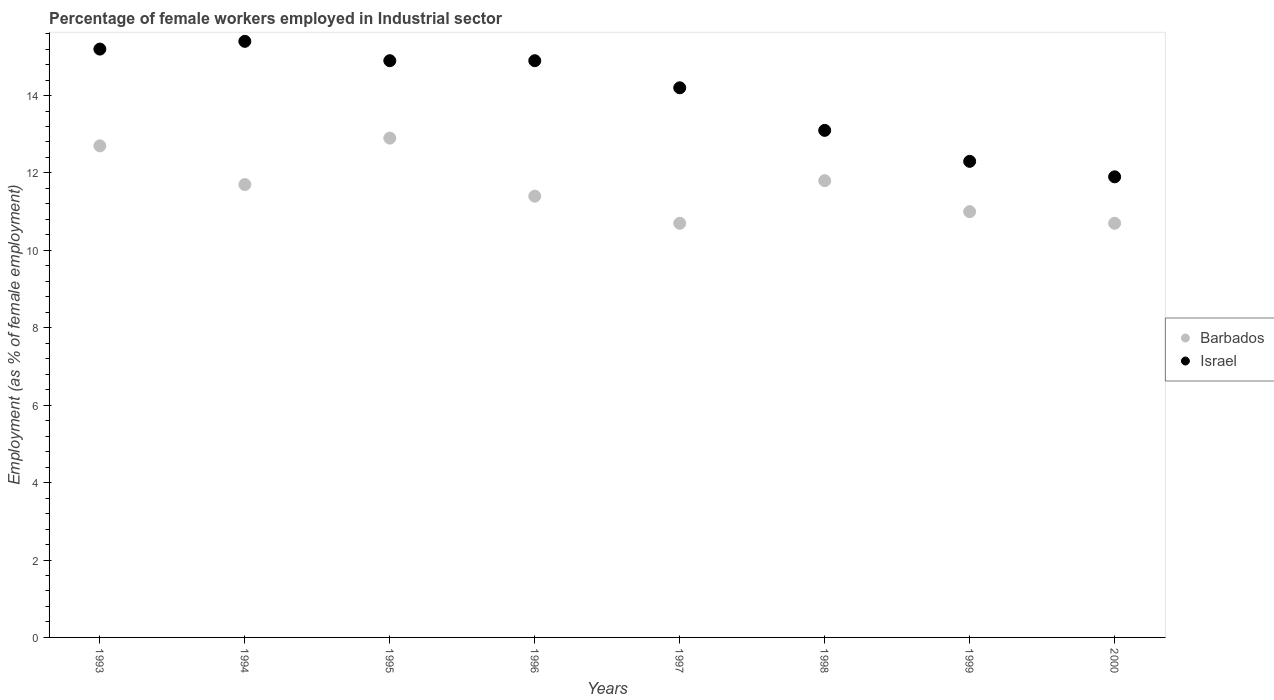What is the percentage of females employed in Industrial sector in Barbados in 1993?
Offer a very short reply. 12.7. Across all years, what is the maximum percentage of females employed in Industrial sector in Israel?
Your answer should be very brief. 15.4. Across all years, what is the minimum percentage of females employed in Industrial sector in Israel?
Offer a very short reply. 11.9. In which year was the percentage of females employed in Industrial sector in Barbados maximum?
Offer a terse response. 1995. What is the total percentage of females employed in Industrial sector in Barbados in the graph?
Ensure brevity in your answer.  92.9. What is the difference between the percentage of females employed in Industrial sector in Barbados in 1996 and that in 2000?
Your response must be concise. 0.7. What is the difference between the percentage of females employed in Industrial sector in Barbados in 1998 and the percentage of females employed in Industrial sector in Israel in 1997?
Provide a short and direct response. -2.4. What is the average percentage of females employed in Industrial sector in Israel per year?
Your answer should be very brief. 13.99. In the year 1998, what is the difference between the percentage of females employed in Industrial sector in Israel and percentage of females employed in Industrial sector in Barbados?
Your response must be concise. 1.3. In how many years, is the percentage of females employed in Industrial sector in Barbados greater than 9.6 %?
Your answer should be compact. 8. What is the ratio of the percentage of females employed in Industrial sector in Barbados in 1998 to that in 1999?
Offer a terse response. 1.07. What is the difference between the highest and the second highest percentage of females employed in Industrial sector in Barbados?
Offer a terse response. 0.2. How many dotlines are there?
Provide a succinct answer. 2. How many years are there in the graph?
Your answer should be compact. 8. What is the difference between two consecutive major ticks on the Y-axis?
Ensure brevity in your answer.  2. Are the values on the major ticks of Y-axis written in scientific E-notation?
Offer a terse response. No. Does the graph contain any zero values?
Your answer should be very brief. No. Does the graph contain grids?
Keep it short and to the point. No. Where does the legend appear in the graph?
Provide a succinct answer. Center right. How many legend labels are there?
Make the answer very short. 2. How are the legend labels stacked?
Provide a succinct answer. Vertical. What is the title of the graph?
Make the answer very short. Percentage of female workers employed in Industrial sector. What is the label or title of the X-axis?
Offer a terse response. Years. What is the label or title of the Y-axis?
Provide a succinct answer. Employment (as % of female employment). What is the Employment (as % of female employment) of Barbados in 1993?
Ensure brevity in your answer.  12.7. What is the Employment (as % of female employment) in Israel in 1993?
Provide a short and direct response. 15.2. What is the Employment (as % of female employment) of Barbados in 1994?
Ensure brevity in your answer.  11.7. What is the Employment (as % of female employment) of Israel in 1994?
Give a very brief answer. 15.4. What is the Employment (as % of female employment) of Barbados in 1995?
Your answer should be compact. 12.9. What is the Employment (as % of female employment) of Israel in 1995?
Your response must be concise. 14.9. What is the Employment (as % of female employment) in Barbados in 1996?
Your response must be concise. 11.4. What is the Employment (as % of female employment) of Israel in 1996?
Keep it short and to the point. 14.9. What is the Employment (as % of female employment) of Barbados in 1997?
Your answer should be very brief. 10.7. What is the Employment (as % of female employment) in Israel in 1997?
Your response must be concise. 14.2. What is the Employment (as % of female employment) of Barbados in 1998?
Offer a very short reply. 11.8. What is the Employment (as % of female employment) of Israel in 1998?
Offer a terse response. 13.1. What is the Employment (as % of female employment) in Barbados in 1999?
Make the answer very short. 11. What is the Employment (as % of female employment) of Israel in 1999?
Offer a terse response. 12.3. What is the Employment (as % of female employment) in Barbados in 2000?
Make the answer very short. 10.7. What is the Employment (as % of female employment) in Israel in 2000?
Your answer should be compact. 11.9. Across all years, what is the maximum Employment (as % of female employment) in Barbados?
Give a very brief answer. 12.9. Across all years, what is the maximum Employment (as % of female employment) in Israel?
Your answer should be very brief. 15.4. Across all years, what is the minimum Employment (as % of female employment) in Barbados?
Make the answer very short. 10.7. Across all years, what is the minimum Employment (as % of female employment) in Israel?
Make the answer very short. 11.9. What is the total Employment (as % of female employment) of Barbados in the graph?
Your answer should be very brief. 92.9. What is the total Employment (as % of female employment) in Israel in the graph?
Provide a succinct answer. 111.9. What is the difference between the Employment (as % of female employment) in Barbados in 1993 and that in 1994?
Give a very brief answer. 1. What is the difference between the Employment (as % of female employment) of Barbados in 1993 and that in 1996?
Your answer should be compact. 1.3. What is the difference between the Employment (as % of female employment) in Israel in 1993 and that in 1996?
Make the answer very short. 0.3. What is the difference between the Employment (as % of female employment) in Barbados in 1993 and that in 1997?
Your answer should be compact. 2. What is the difference between the Employment (as % of female employment) of Israel in 1993 and that in 1997?
Ensure brevity in your answer.  1. What is the difference between the Employment (as % of female employment) in Israel in 1993 and that in 1999?
Give a very brief answer. 2.9. What is the difference between the Employment (as % of female employment) in Barbados in 1993 and that in 2000?
Your response must be concise. 2. What is the difference between the Employment (as % of female employment) in Barbados in 1994 and that in 1996?
Your answer should be compact. 0.3. What is the difference between the Employment (as % of female employment) in Israel in 1994 and that in 1996?
Your answer should be compact. 0.5. What is the difference between the Employment (as % of female employment) of Barbados in 1994 and that in 1997?
Provide a short and direct response. 1. What is the difference between the Employment (as % of female employment) of Israel in 1994 and that in 1998?
Make the answer very short. 2.3. What is the difference between the Employment (as % of female employment) of Israel in 1994 and that in 1999?
Keep it short and to the point. 3.1. What is the difference between the Employment (as % of female employment) in Barbados in 1994 and that in 2000?
Ensure brevity in your answer.  1. What is the difference between the Employment (as % of female employment) in Israel in 1994 and that in 2000?
Your response must be concise. 3.5. What is the difference between the Employment (as % of female employment) of Israel in 1995 and that in 1996?
Provide a succinct answer. 0. What is the difference between the Employment (as % of female employment) of Israel in 1995 and that in 1998?
Give a very brief answer. 1.8. What is the difference between the Employment (as % of female employment) in Israel in 1995 and that in 2000?
Ensure brevity in your answer.  3. What is the difference between the Employment (as % of female employment) of Barbados in 1996 and that in 1997?
Offer a very short reply. 0.7. What is the difference between the Employment (as % of female employment) in Barbados in 1997 and that in 1998?
Offer a very short reply. -1.1. What is the difference between the Employment (as % of female employment) of Barbados in 1997 and that in 1999?
Provide a short and direct response. -0.3. What is the difference between the Employment (as % of female employment) of Barbados in 1997 and that in 2000?
Your response must be concise. 0. What is the difference between the Employment (as % of female employment) in Israel in 1997 and that in 2000?
Your response must be concise. 2.3. What is the difference between the Employment (as % of female employment) in Israel in 1998 and that in 1999?
Your answer should be very brief. 0.8. What is the difference between the Employment (as % of female employment) of Barbados in 1998 and that in 2000?
Give a very brief answer. 1.1. What is the difference between the Employment (as % of female employment) of Israel in 1998 and that in 2000?
Your answer should be very brief. 1.2. What is the difference between the Employment (as % of female employment) of Barbados in 1993 and the Employment (as % of female employment) of Israel in 1995?
Ensure brevity in your answer.  -2.2. What is the difference between the Employment (as % of female employment) in Barbados in 1993 and the Employment (as % of female employment) in Israel in 1996?
Provide a short and direct response. -2.2. What is the difference between the Employment (as % of female employment) of Barbados in 1993 and the Employment (as % of female employment) of Israel in 1997?
Your answer should be compact. -1.5. What is the difference between the Employment (as % of female employment) of Barbados in 1993 and the Employment (as % of female employment) of Israel in 1998?
Your answer should be very brief. -0.4. What is the difference between the Employment (as % of female employment) in Barbados in 1993 and the Employment (as % of female employment) in Israel in 1999?
Provide a succinct answer. 0.4. What is the difference between the Employment (as % of female employment) of Barbados in 1993 and the Employment (as % of female employment) of Israel in 2000?
Ensure brevity in your answer.  0.8. What is the difference between the Employment (as % of female employment) in Barbados in 1994 and the Employment (as % of female employment) in Israel in 1997?
Provide a short and direct response. -2.5. What is the difference between the Employment (as % of female employment) in Barbados in 1994 and the Employment (as % of female employment) in Israel in 1998?
Your response must be concise. -1.4. What is the difference between the Employment (as % of female employment) in Barbados in 1995 and the Employment (as % of female employment) in Israel in 1996?
Provide a short and direct response. -2. What is the difference between the Employment (as % of female employment) in Barbados in 1995 and the Employment (as % of female employment) in Israel in 1997?
Provide a short and direct response. -1.3. What is the difference between the Employment (as % of female employment) of Barbados in 1995 and the Employment (as % of female employment) of Israel in 1999?
Provide a short and direct response. 0.6. What is the difference between the Employment (as % of female employment) in Barbados in 1996 and the Employment (as % of female employment) in Israel in 1997?
Your answer should be compact. -2.8. What is the difference between the Employment (as % of female employment) in Barbados in 1996 and the Employment (as % of female employment) in Israel in 1998?
Provide a short and direct response. -1.7. What is the difference between the Employment (as % of female employment) in Barbados in 1996 and the Employment (as % of female employment) in Israel in 2000?
Provide a succinct answer. -0.5. What is the difference between the Employment (as % of female employment) of Barbados in 1997 and the Employment (as % of female employment) of Israel in 2000?
Your answer should be very brief. -1.2. What is the average Employment (as % of female employment) of Barbados per year?
Offer a terse response. 11.61. What is the average Employment (as % of female employment) in Israel per year?
Keep it short and to the point. 13.99. In the year 1996, what is the difference between the Employment (as % of female employment) in Barbados and Employment (as % of female employment) in Israel?
Your response must be concise. -3.5. In the year 1998, what is the difference between the Employment (as % of female employment) of Barbados and Employment (as % of female employment) of Israel?
Offer a very short reply. -1.3. In the year 2000, what is the difference between the Employment (as % of female employment) of Barbados and Employment (as % of female employment) of Israel?
Your answer should be very brief. -1.2. What is the ratio of the Employment (as % of female employment) in Barbados in 1993 to that in 1994?
Offer a very short reply. 1.09. What is the ratio of the Employment (as % of female employment) of Barbados in 1993 to that in 1995?
Provide a succinct answer. 0.98. What is the ratio of the Employment (as % of female employment) in Israel in 1993 to that in 1995?
Keep it short and to the point. 1.02. What is the ratio of the Employment (as % of female employment) in Barbados in 1993 to that in 1996?
Make the answer very short. 1.11. What is the ratio of the Employment (as % of female employment) in Israel in 1993 to that in 1996?
Keep it short and to the point. 1.02. What is the ratio of the Employment (as % of female employment) of Barbados in 1993 to that in 1997?
Provide a short and direct response. 1.19. What is the ratio of the Employment (as % of female employment) of Israel in 1993 to that in 1997?
Offer a terse response. 1.07. What is the ratio of the Employment (as % of female employment) in Barbados in 1993 to that in 1998?
Offer a terse response. 1.08. What is the ratio of the Employment (as % of female employment) of Israel in 1993 to that in 1998?
Offer a terse response. 1.16. What is the ratio of the Employment (as % of female employment) of Barbados in 1993 to that in 1999?
Keep it short and to the point. 1.15. What is the ratio of the Employment (as % of female employment) of Israel in 1993 to that in 1999?
Your response must be concise. 1.24. What is the ratio of the Employment (as % of female employment) in Barbados in 1993 to that in 2000?
Your answer should be very brief. 1.19. What is the ratio of the Employment (as % of female employment) in Israel in 1993 to that in 2000?
Your response must be concise. 1.28. What is the ratio of the Employment (as % of female employment) of Barbados in 1994 to that in 1995?
Your answer should be very brief. 0.91. What is the ratio of the Employment (as % of female employment) of Israel in 1994 to that in 1995?
Provide a succinct answer. 1.03. What is the ratio of the Employment (as % of female employment) of Barbados in 1994 to that in 1996?
Provide a short and direct response. 1.03. What is the ratio of the Employment (as % of female employment) in Israel in 1994 to that in 1996?
Give a very brief answer. 1.03. What is the ratio of the Employment (as % of female employment) in Barbados in 1994 to that in 1997?
Provide a short and direct response. 1.09. What is the ratio of the Employment (as % of female employment) of Israel in 1994 to that in 1997?
Provide a short and direct response. 1.08. What is the ratio of the Employment (as % of female employment) of Israel in 1994 to that in 1998?
Your response must be concise. 1.18. What is the ratio of the Employment (as % of female employment) in Barbados in 1994 to that in 1999?
Provide a succinct answer. 1.06. What is the ratio of the Employment (as % of female employment) of Israel in 1994 to that in 1999?
Your answer should be compact. 1.25. What is the ratio of the Employment (as % of female employment) of Barbados in 1994 to that in 2000?
Your answer should be compact. 1.09. What is the ratio of the Employment (as % of female employment) in Israel in 1994 to that in 2000?
Your response must be concise. 1.29. What is the ratio of the Employment (as % of female employment) in Barbados in 1995 to that in 1996?
Your response must be concise. 1.13. What is the ratio of the Employment (as % of female employment) in Barbados in 1995 to that in 1997?
Your answer should be compact. 1.21. What is the ratio of the Employment (as % of female employment) in Israel in 1995 to that in 1997?
Your answer should be compact. 1.05. What is the ratio of the Employment (as % of female employment) in Barbados in 1995 to that in 1998?
Provide a short and direct response. 1.09. What is the ratio of the Employment (as % of female employment) in Israel in 1995 to that in 1998?
Ensure brevity in your answer.  1.14. What is the ratio of the Employment (as % of female employment) of Barbados in 1995 to that in 1999?
Give a very brief answer. 1.17. What is the ratio of the Employment (as % of female employment) of Israel in 1995 to that in 1999?
Provide a succinct answer. 1.21. What is the ratio of the Employment (as % of female employment) in Barbados in 1995 to that in 2000?
Ensure brevity in your answer.  1.21. What is the ratio of the Employment (as % of female employment) of Israel in 1995 to that in 2000?
Ensure brevity in your answer.  1.25. What is the ratio of the Employment (as % of female employment) in Barbados in 1996 to that in 1997?
Your response must be concise. 1.07. What is the ratio of the Employment (as % of female employment) of Israel in 1996 to that in 1997?
Your answer should be compact. 1.05. What is the ratio of the Employment (as % of female employment) in Barbados in 1996 to that in 1998?
Your answer should be very brief. 0.97. What is the ratio of the Employment (as % of female employment) of Israel in 1996 to that in 1998?
Keep it short and to the point. 1.14. What is the ratio of the Employment (as % of female employment) of Barbados in 1996 to that in 1999?
Your response must be concise. 1.04. What is the ratio of the Employment (as % of female employment) in Israel in 1996 to that in 1999?
Your answer should be very brief. 1.21. What is the ratio of the Employment (as % of female employment) in Barbados in 1996 to that in 2000?
Your response must be concise. 1.07. What is the ratio of the Employment (as % of female employment) in Israel in 1996 to that in 2000?
Provide a short and direct response. 1.25. What is the ratio of the Employment (as % of female employment) of Barbados in 1997 to that in 1998?
Give a very brief answer. 0.91. What is the ratio of the Employment (as % of female employment) in Israel in 1997 to that in 1998?
Offer a very short reply. 1.08. What is the ratio of the Employment (as % of female employment) in Barbados in 1997 to that in 1999?
Your response must be concise. 0.97. What is the ratio of the Employment (as % of female employment) in Israel in 1997 to that in 1999?
Your answer should be compact. 1.15. What is the ratio of the Employment (as % of female employment) of Israel in 1997 to that in 2000?
Offer a terse response. 1.19. What is the ratio of the Employment (as % of female employment) in Barbados in 1998 to that in 1999?
Give a very brief answer. 1.07. What is the ratio of the Employment (as % of female employment) of Israel in 1998 to that in 1999?
Offer a terse response. 1.06. What is the ratio of the Employment (as % of female employment) in Barbados in 1998 to that in 2000?
Your response must be concise. 1.1. What is the ratio of the Employment (as % of female employment) of Israel in 1998 to that in 2000?
Keep it short and to the point. 1.1. What is the ratio of the Employment (as % of female employment) of Barbados in 1999 to that in 2000?
Provide a succinct answer. 1.03. What is the ratio of the Employment (as % of female employment) in Israel in 1999 to that in 2000?
Your answer should be compact. 1.03. What is the difference between the highest and the lowest Employment (as % of female employment) of Barbados?
Offer a very short reply. 2.2. 